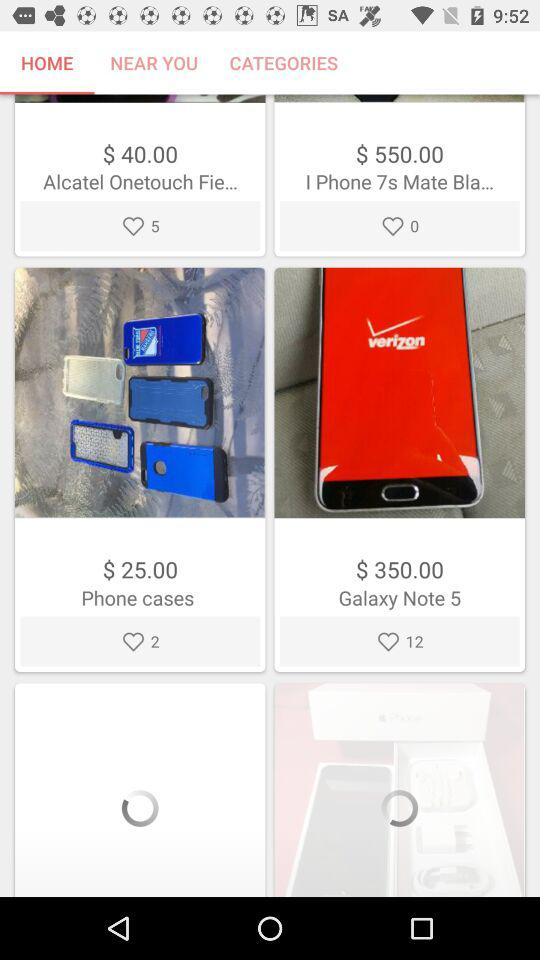Which tab is selected? The selected tab is "HOME". 